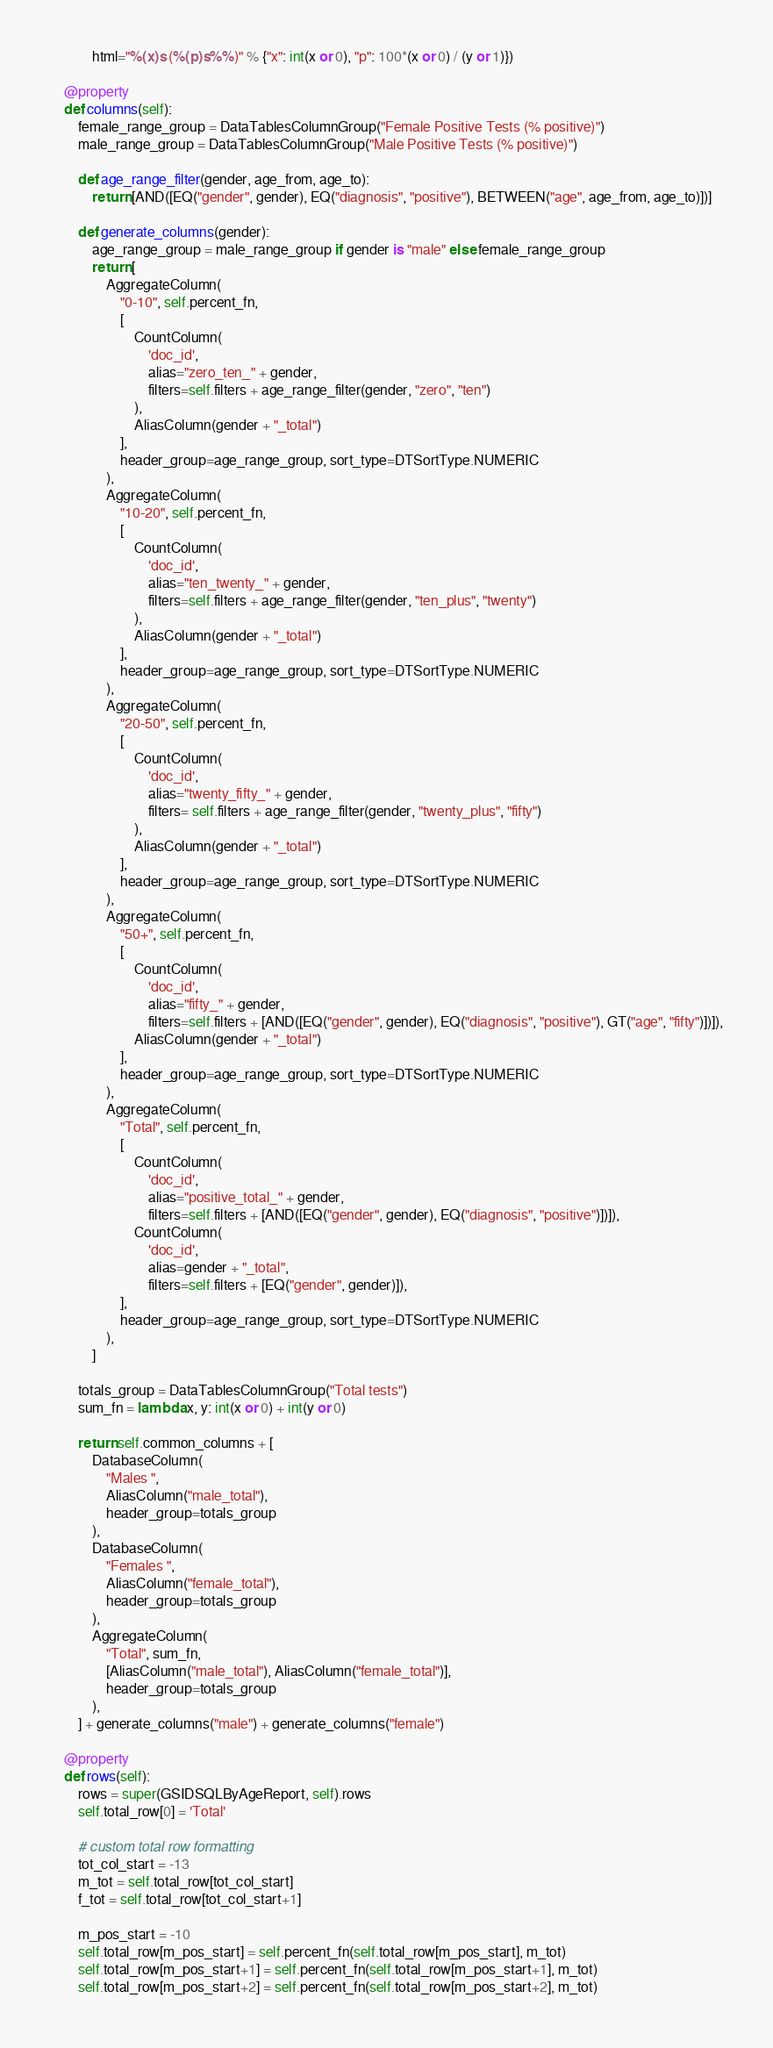<code> <loc_0><loc_0><loc_500><loc_500><_Python_>            html="%(x)s (%(p)s%%)" % {"x": int(x or 0), "p": 100*(x or 0) / (y or 1)})

    @property
    def columns(self):
        female_range_group = DataTablesColumnGroup("Female Positive Tests (% positive)")
        male_range_group = DataTablesColumnGroup("Male Positive Tests (% positive)")

        def age_range_filter(gender, age_from, age_to):
            return [AND([EQ("gender", gender), EQ("diagnosis", "positive"), BETWEEN("age", age_from, age_to)])]

        def generate_columns(gender):
            age_range_group = male_range_group if gender is "male" else female_range_group
            return [
                AggregateColumn(
                    "0-10", self.percent_fn,
                    [   
                        CountColumn(
                            'doc_id',
                            alias="zero_ten_" + gender, 
                            filters=self.filters + age_range_filter(gender, "zero", "ten")
                        ),
                        AliasColumn(gender + "_total")
                    ],
                    header_group=age_range_group, sort_type=DTSortType.NUMERIC
                ),
                AggregateColumn(
                    "10-20", self.percent_fn,
                    [
                        CountColumn(
                            'doc_id',
                            alias="ten_twenty_" + gender, 
                            filters=self.filters + age_range_filter(gender, "ten_plus", "twenty")
                        ),
                        AliasColumn(gender + "_total")
                    ],
                    header_group=age_range_group, sort_type=DTSortType.NUMERIC
                ),
                AggregateColumn(
                    "20-50", self.percent_fn,
                    [
                        CountColumn(
                            'doc_id',
                            alias="twenty_fifty_" + gender, 
                            filters= self.filters + age_range_filter(gender, "twenty_plus", "fifty")
                        ),
                        AliasColumn(gender + "_total")
                    ],
                    header_group=age_range_group, sort_type=DTSortType.NUMERIC
                ),
                AggregateColumn(
                    "50+", self.percent_fn,
                    [
                        CountColumn(
                            'doc_id',
                            alias="fifty_" + gender, 
                            filters=self.filters + [AND([EQ("gender", gender), EQ("diagnosis", "positive"), GT("age", "fifty")])]),
                        AliasColumn(gender + "_total")
                    ],
                    header_group=age_range_group, sort_type=DTSortType.NUMERIC
                ),
                AggregateColumn(
                    "Total", self.percent_fn,
                    [
                        CountColumn(
                            'doc_id',
                            alias="positive_total_" + gender,
                            filters=self.filters + [AND([EQ("gender", gender), EQ("diagnosis", "positive")])]),
                        CountColumn(
                            'doc_id',
                            alias=gender + "_total",
                            filters=self.filters + [EQ("gender", gender)]),
                    ],
                    header_group=age_range_group, sort_type=DTSortType.NUMERIC
                ),
            ]
        
        totals_group = DataTablesColumnGroup("Total tests")
        sum_fn = lambda x, y: int(x or 0) + int(y or 0)

        return self.common_columns + [
            DatabaseColumn(
                "Males ",
                AliasColumn("male_total"),
                header_group=totals_group
            ),
            DatabaseColumn(
                "Females ",
                AliasColumn("female_total"),
                header_group=totals_group
            ),
            AggregateColumn(
                "Total", sum_fn,
                [AliasColumn("male_total"), AliasColumn("female_total")],
                header_group=totals_group
            ),
        ] + generate_columns("male") + generate_columns("female")

    @property
    def rows(self):
        rows = super(GSIDSQLByAgeReport, self).rows
        self.total_row[0] = 'Total'

        # custom total row formatting
        tot_col_start = -13
        m_tot = self.total_row[tot_col_start]
        f_tot = self.total_row[tot_col_start+1]

        m_pos_start = -10
        self.total_row[m_pos_start] = self.percent_fn(self.total_row[m_pos_start], m_tot)
        self.total_row[m_pos_start+1] = self.percent_fn(self.total_row[m_pos_start+1], m_tot)
        self.total_row[m_pos_start+2] = self.percent_fn(self.total_row[m_pos_start+2], m_tot)</code> 